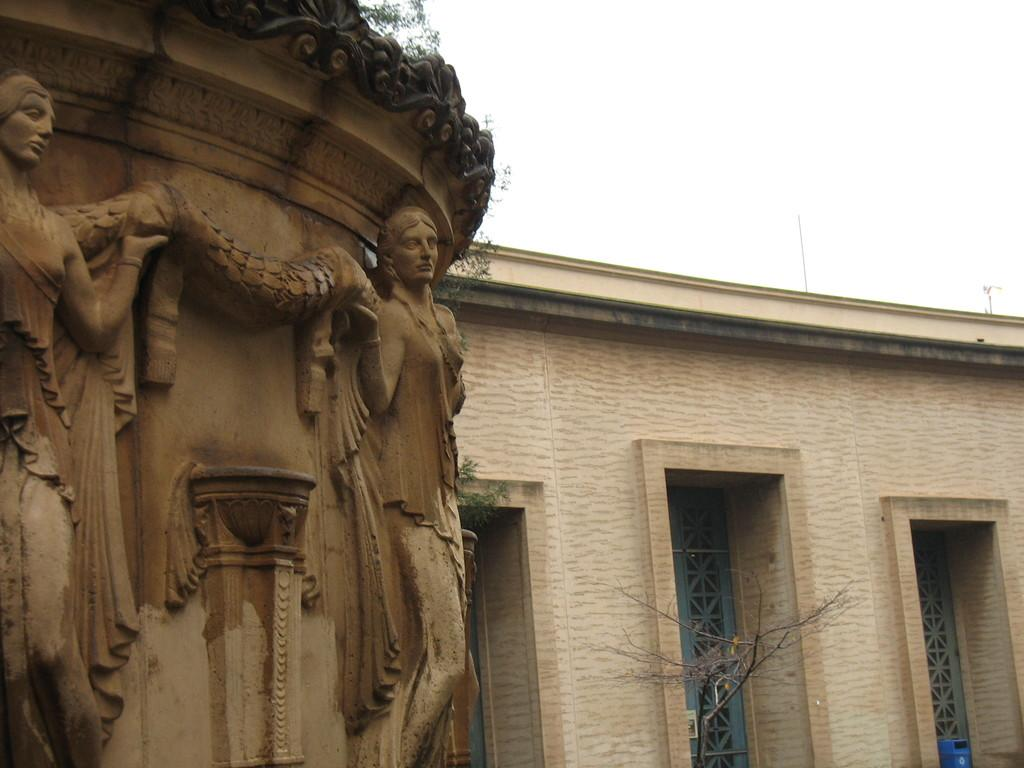What type of structure is present in the image? There is a building in the image. What can be seen on the wall of the building? There is a sculpture on the wall of the building. What type of natural element is visible in the image? There is a tree visible in the image. What type of amusement can be seen on the tray in the image? There is no tray present in the image, so it is not possible to answer that question. 